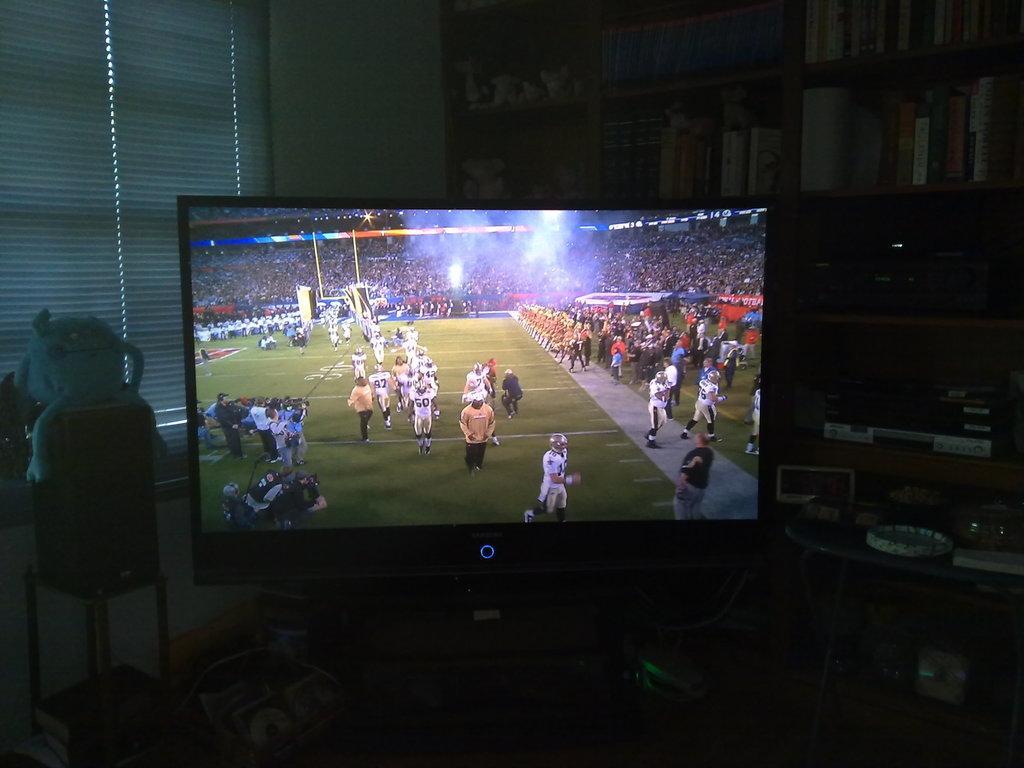Please provide a concise description of this image. In the center of the image there is a television. Image also consists of a toy, plate and bowl on the table. In the background we can see a window mat and we can also see some books placed in a wooden shelf. 